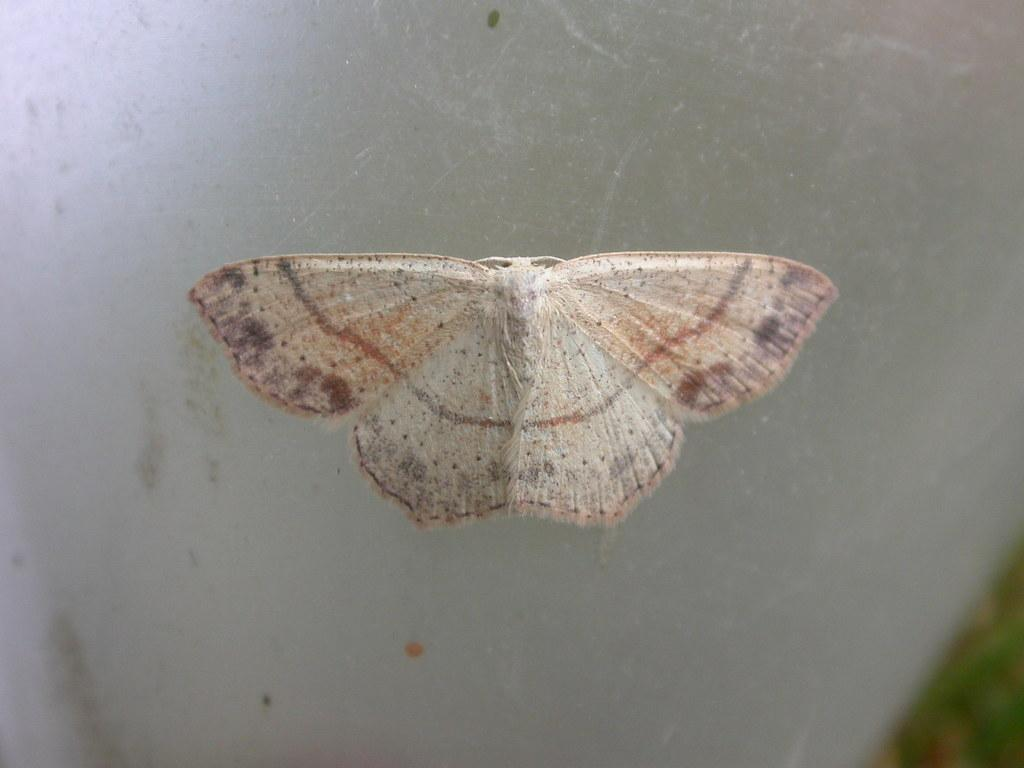What is the main subject of the image? There is a butterfly in the image. Where is the butterfly located? The butterfly is on a glass surface. Can you describe the background of the image? The background of the image is blurred. How many fingers can be seen touching the butterfly in the image? There are no fingers touching the butterfly in the image. Is the butterfly flying in the image? The image does not show the butterfly in flight; it is on a glass surface. 